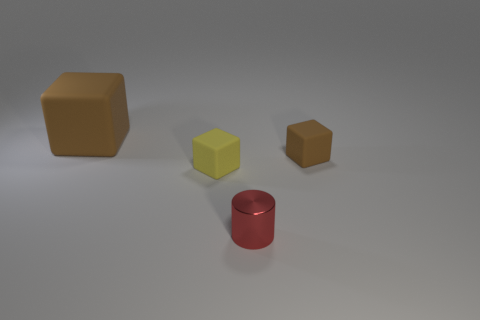Subtract all yellow cylinders. How many brown blocks are left? 2 Add 2 tiny yellow cubes. How many objects exist? 6 Subtract all blocks. How many objects are left? 1 Add 2 tiny yellow metallic spheres. How many tiny yellow metallic spheres exist? 2 Subtract 0 purple cylinders. How many objects are left? 4 Subtract all brown blocks. Subtract all tiny blocks. How many objects are left? 0 Add 4 yellow matte blocks. How many yellow matte blocks are left? 5 